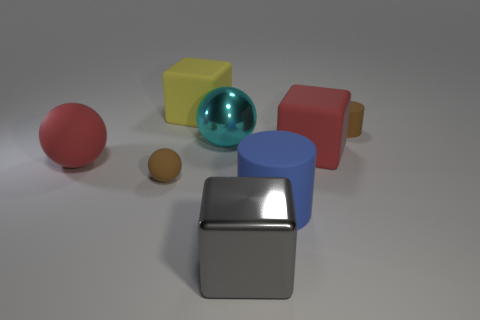The shiny thing that is in front of the large matte object that is right of the large blue matte cylinder is what color?
Provide a succinct answer. Gray. There is a big yellow thing; what shape is it?
Ensure brevity in your answer.  Cube. Is the size of the rubber cube that is right of the gray block the same as the big red ball?
Make the answer very short. Yes. Are there any balls made of the same material as the large yellow thing?
Your answer should be very brief. Yes. What number of objects are either objects that are to the right of the big blue cylinder or red matte things?
Your response must be concise. 3. Are there any yellow balls?
Provide a succinct answer. No. What is the shape of the big matte thing that is left of the large blue object and in front of the tiny cylinder?
Keep it short and to the point. Sphere. How big is the red thing on the right side of the yellow block?
Offer a terse response. Large. Do the cylinder right of the blue cylinder and the metal sphere have the same color?
Provide a succinct answer. No. How many gray metal things are the same shape as the yellow matte thing?
Offer a very short reply. 1. 